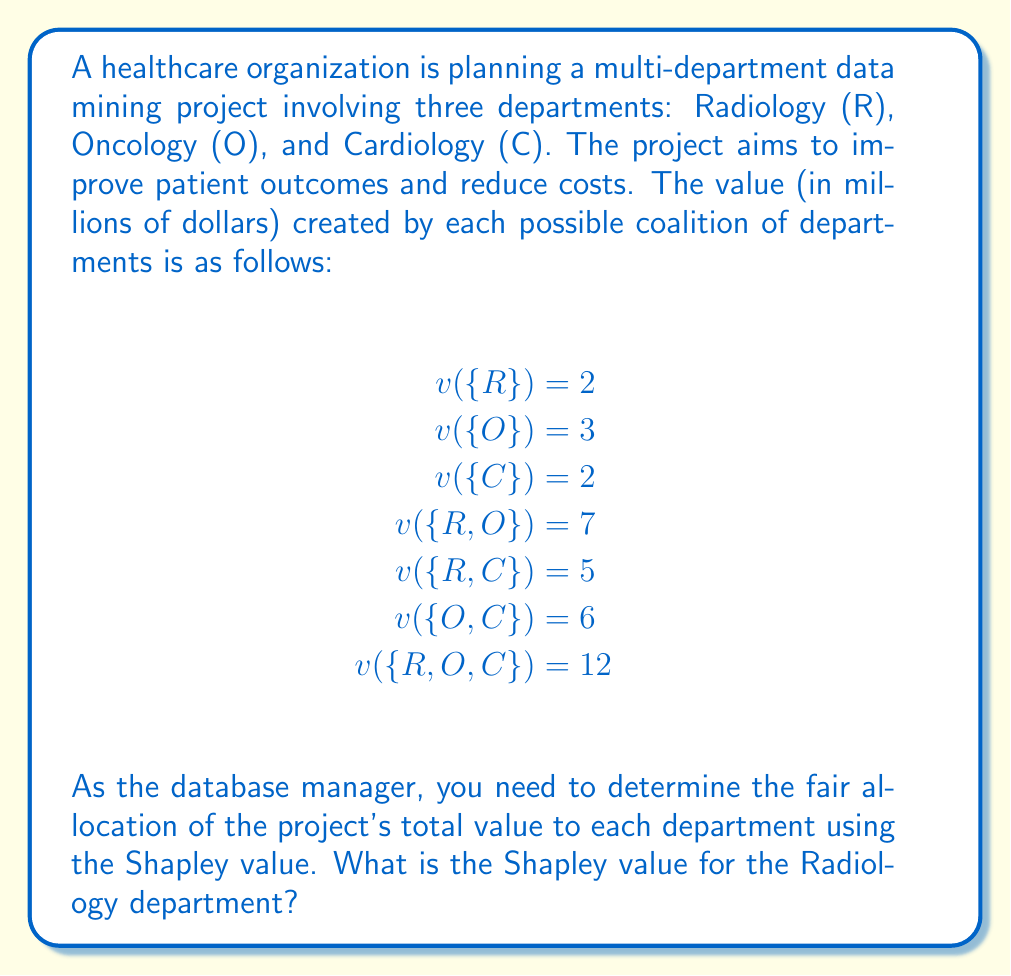Can you answer this question? To solve this problem, we need to calculate the Shapley value for the Radiology department using the Shapley value formula:

$$\phi_i(v) = \sum_{S \subseteq N \setminus \{i\}} \frac{|S|!(n-|S|-1)!}{n!}[v(S \cup \{i\}) - v(S)]$$

Where:
$\phi_i(v)$ is the Shapley value for player $i$ (in this case, Radiology)
$N$ is the set of all players
$S$ is a subset of $N$ not containing $i$
$n$ is the total number of players
$v(S)$ is the characteristic function that gives the value of coalition $S$

For the Radiology department, we need to consider all possible coalitions and calculate its marginal contribution:

1. Empty set $\{\}$: 
   Contribution = $v(\{R\}) - v(\{\}) = 2 - 0 = 2$
   Weight = $\frac{0!(3-0-1)!}{3!} = \frac{2}{6} = \frac{1}{3}$

2. Oncology $\{O\}$: 
   Contribution = $v(\{R,O\}) - v(\{O\}) = 7 - 3 = 4$
   Weight = $\frac{1!(3-1-1)!}{3!} = \frac{1}{6}$

3. Cardiology $\{C\}$: 
   Contribution = $v(\{R,C\}) - v(\{C\}) = 5 - 2 = 3$
   Weight = $\frac{1!(3-1-1)!}{3!} = \frac{1}{6}$

4. Oncology and Cardiology $\{O,C\}$: 
   Contribution = $v(\{R,O,C\}) - v(\{O,C\}) = 12 - 6 = 6$
   Weight = $\frac{2!(3-2-1)!}{3!} = \frac{1}{3}$

Now, we can calculate the Shapley value for Radiology:

$$\phi_R(v) = (2 \cdot \frac{1}{3}) + (4 \cdot \frac{1}{6}) + (3 \cdot \frac{1}{6}) + (6 \cdot \frac{1}{3})$$

$$\phi_R(v) = \frac{2}{3} + \frac{2}{3} + \frac{1}{2} + 2 = \frac{23}{6} = 3.8333...$$

Therefore, the Shapley value for the Radiology department is approximately 3.83 million dollars.
Answer: $3.83$ million dollars (rounded to two decimal places) 